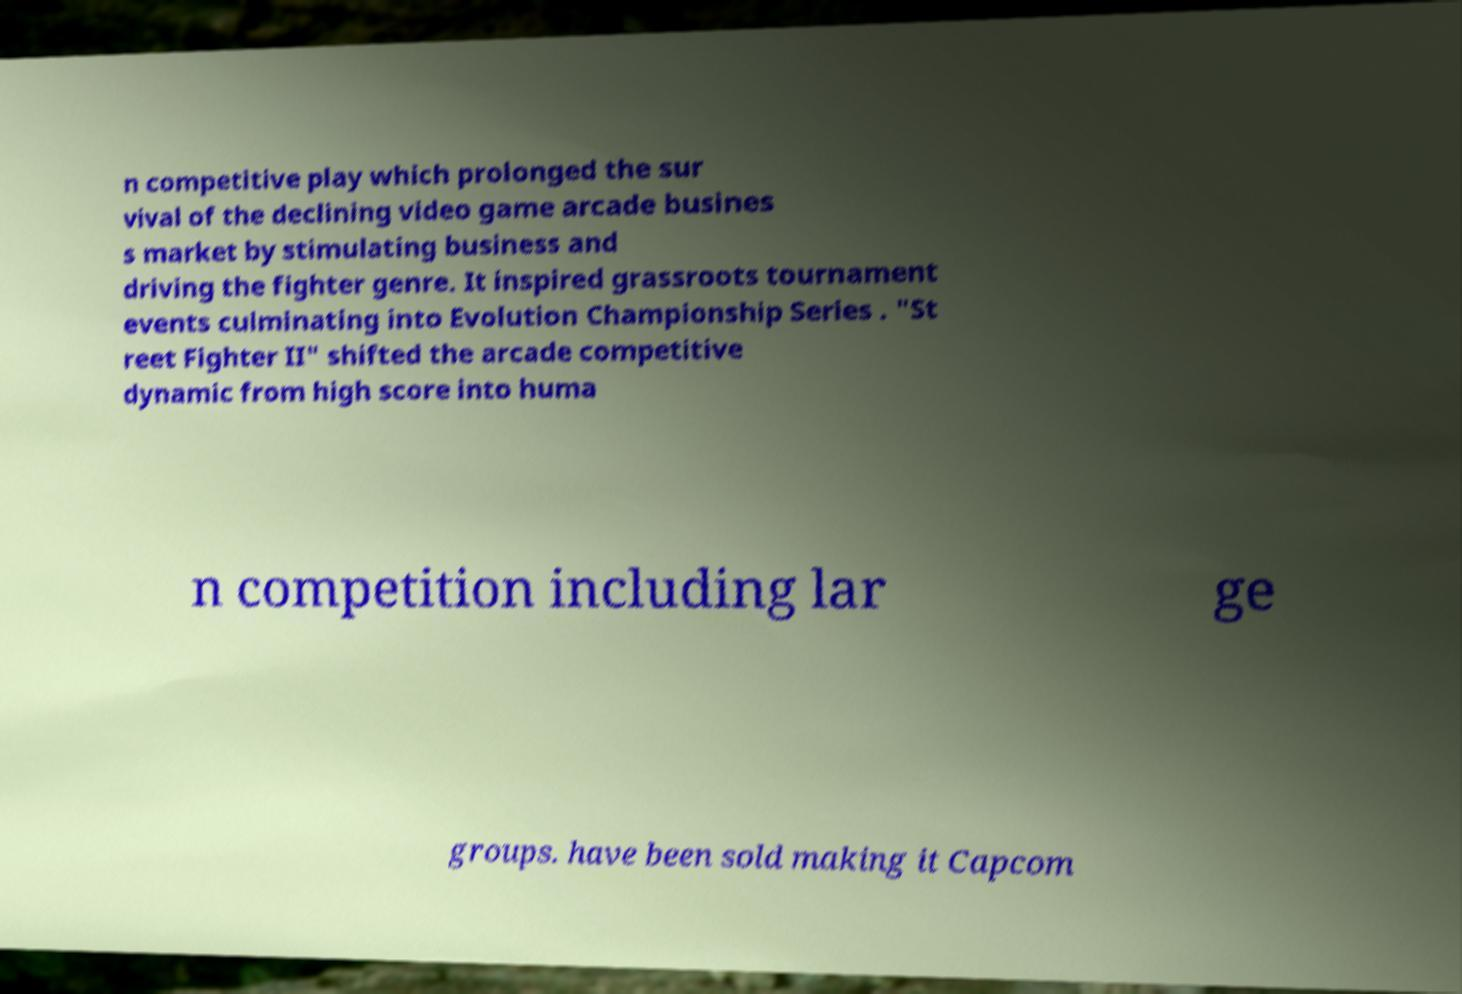Can you accurately transcribe the text from the provided image for me? n competitive play which prolonged the sur vival of the declining video game arcade busines s market by stimulating business and driving the fighter genre. It inspired grassroots tournament events culminating into Evolution Championship Series . "St reet Fighter II" shifted the arcade competitive dynamic from high score into huma n competition including lar ge groups. have been sold making it Capcom 